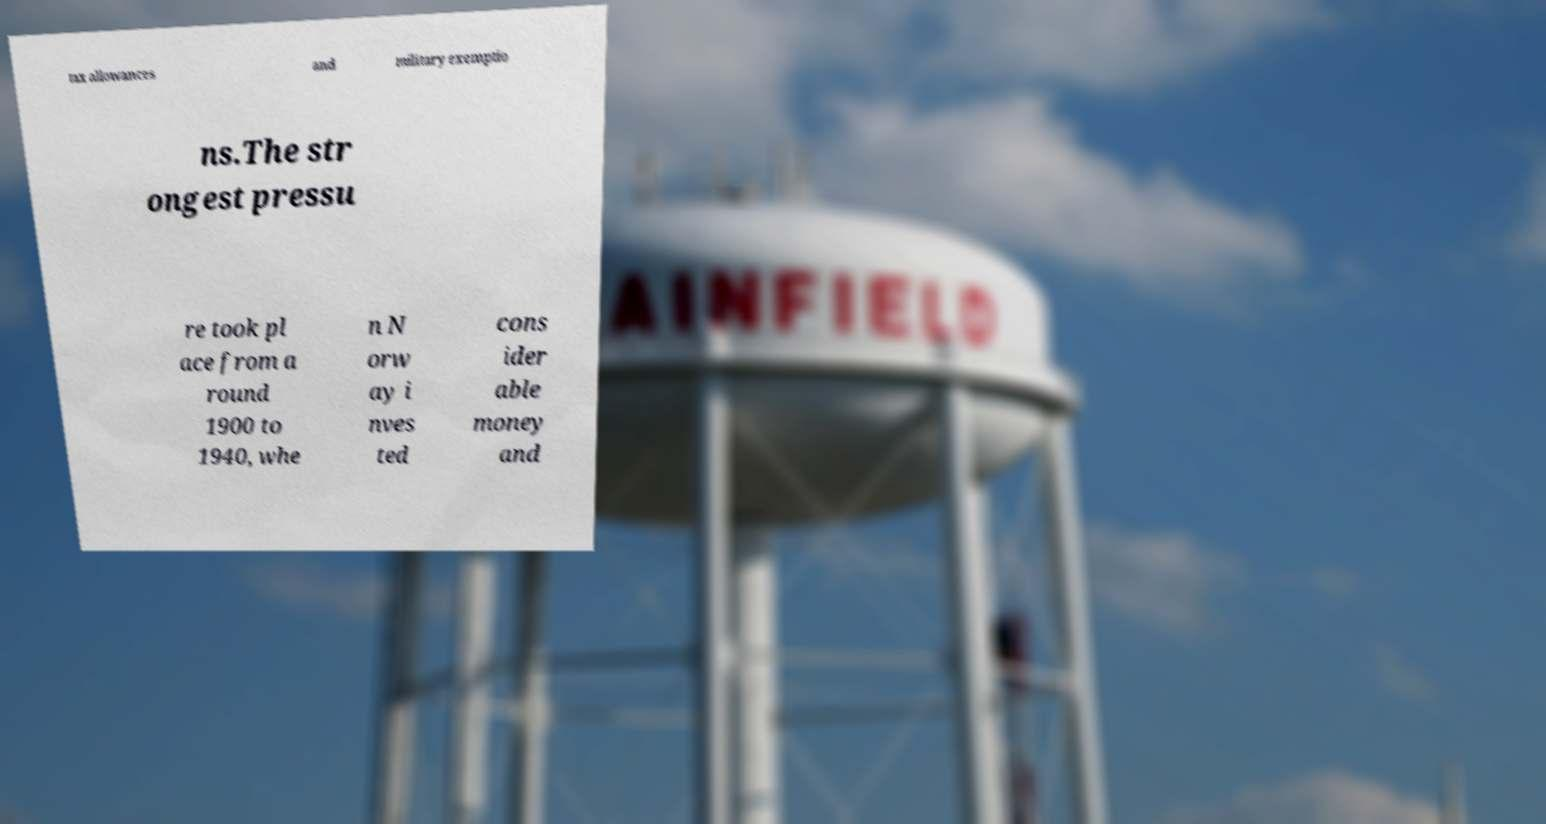What messages or text are displayed in this image? I need them in a readable, typed format. tax allowances and military exemptio ns.The str ongest pressu re took pl ace from a round 1900 to 1940, whe n N orw ay i nves ted cons ider able money and 